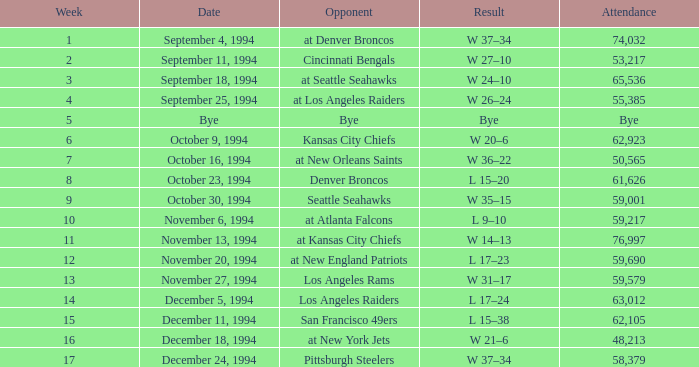In the contest against the pittsburgh steelers, what was the crowd size? 58379.0. 